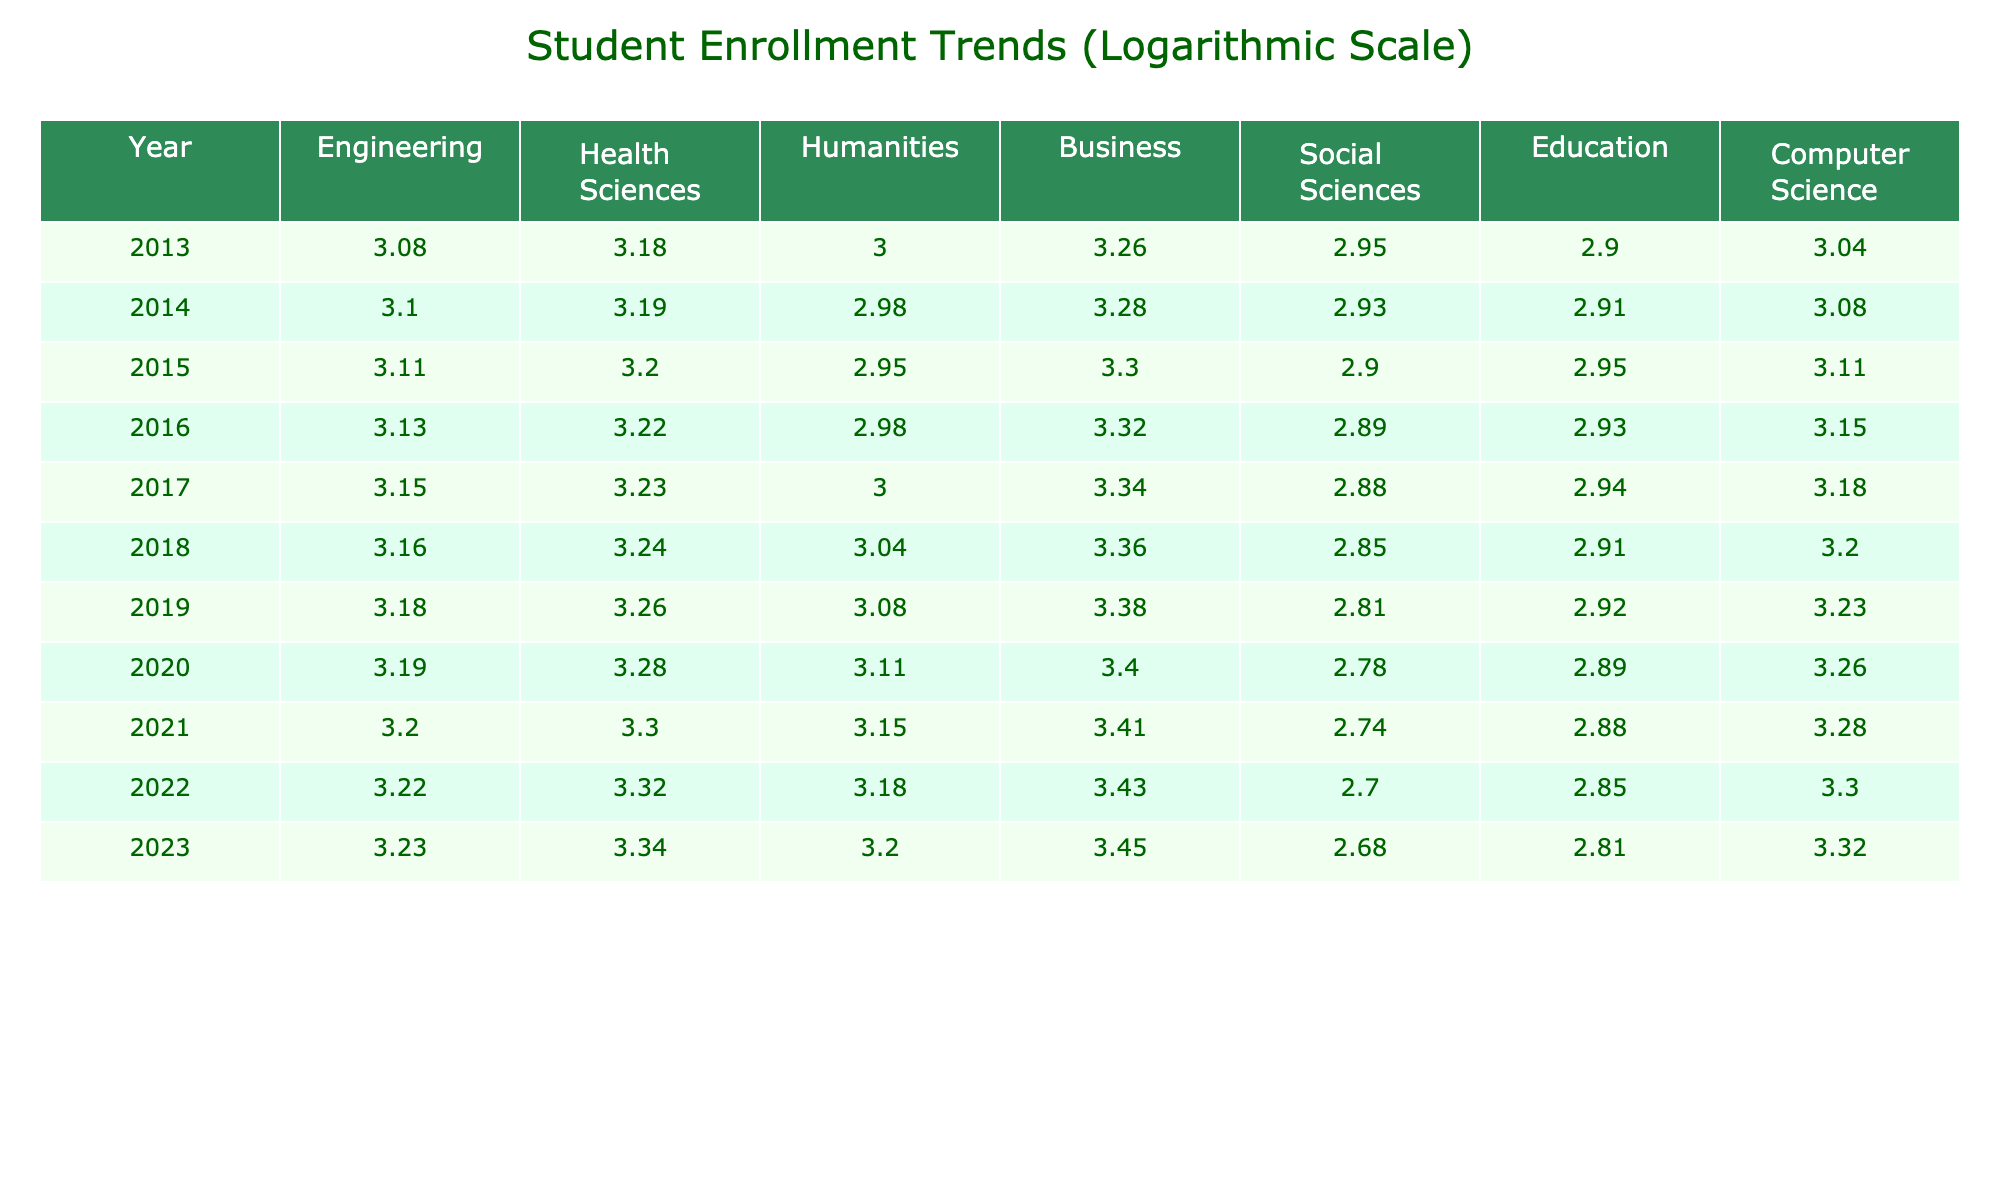What is the logarithmic value of student enrollment in Health Sciences for the year 2023? From the table, the enrollment in Health Sciences for 2023 is 2200. The logarithmic value is calculated as log10(2200) which equals approximately 3.34.
Answer: 3.34 What was the enrollment trend in Engineering from 2013 to 2023? To determine the trend, we observe the logarithmic values for Engineering each year. The values increase from log10(1200) in 2013 to log10(1700) in 2023, suggesting a consistent upward trend over the decade.
Answer: Increasing What is the average logarithmic enrollment value for Computer Science from 2013 to 2023? First, we find the logarithmic values for Computer Science: log10(1100), log10(1200), log10(1300), log10(1400), log10(1500), log10(1600), log10(1700), log10(1800), log10(1900), log10(2000), log10(2100) and sum them. The total is approximately 17.47, and then we divide by the number of years (11) to get an average of approximately 1.59.
Answer: 1.59 Do more students enroll in Business or Social Sciences based on the logarithmic values for 2023? In 2023, the logarithmic values are log10(2800) for Business and log10(480) for Social Sciences. Since 2800 is greater than 480, this indicates that Business has a higher enrollment.
Answer: Yes (Business has more students) What is the percentage increase in enrollment for Education from 2013 to 2023? The enrollment in Education for 2013 was 800 and for 2023 it is 650. To find the percentage change, we use the formula: [(650 - 800) / 800] * 100 = -18.75%. This negative value indicates a decrease in enrollment.
Answer: -18.75% What is the difference in logarithmic enrollment between Health Sciences and Humanities for the year 2020? The values for Health Sciences and Humanities in 2020 are log10(1900) and log10(1300), respectively. We subtract the latter from the former: log10(1900) - log10(1300) = log10(1900/1300), which calculates to approximately 0.24.
Answer: 0.24 What is the lowest logarithmic enrollment value across all years for Social Sciences? By analyzing the logarithmic values for Social Sciences each year, the lowest value is log10(480) which corresponds to the year 2023.
Answer: log10(480) Is there a year when the enrollment in Health Sciences dropped compared to the previous year? By examining the yearly data closely, we see that Health Sciences enrollment steadily increases every year from 2013 to 2023 without any drop in any year.
Answer: No 